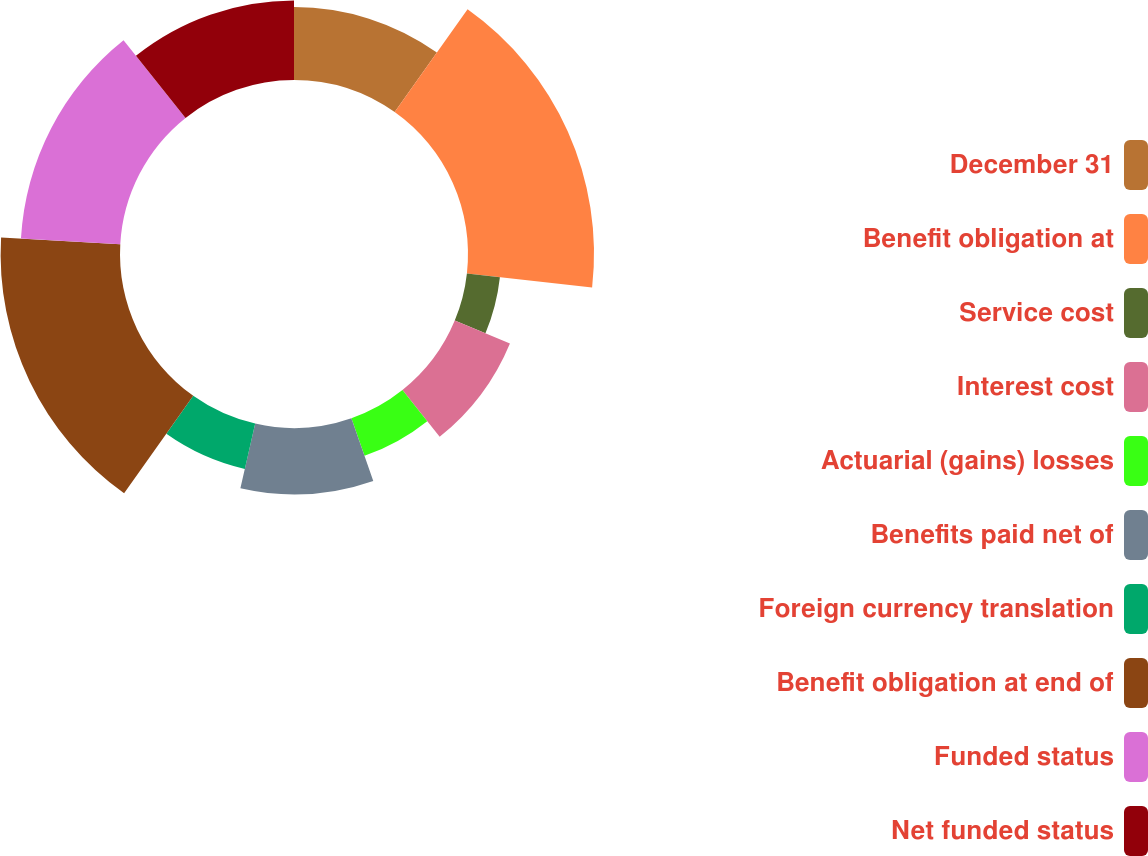Convert chart to OTSL. <chart><loc_0><loc_0><loc_500><loc_500><pie_chart><fcel>December 31<fcel>Benefit obligation at<fcel>Service cost<fcel>Interest cost<fcel>Actuarial (gains) losses<fcel>Benefits paid net of<fcel>Foreign currency translation<fcel>Benefit obligation at end of<fcel>Funded status<fcel>Net funded status<nl><fcel>9.82%<fcel>16.96%<fcel>4.47%<fcel>8.04%<fcel>5.36%<fcel>8.93%<fcel>6.25%<fcel>16.07%<fcel>13.39%<fcel>10.71%<nl></chart> 